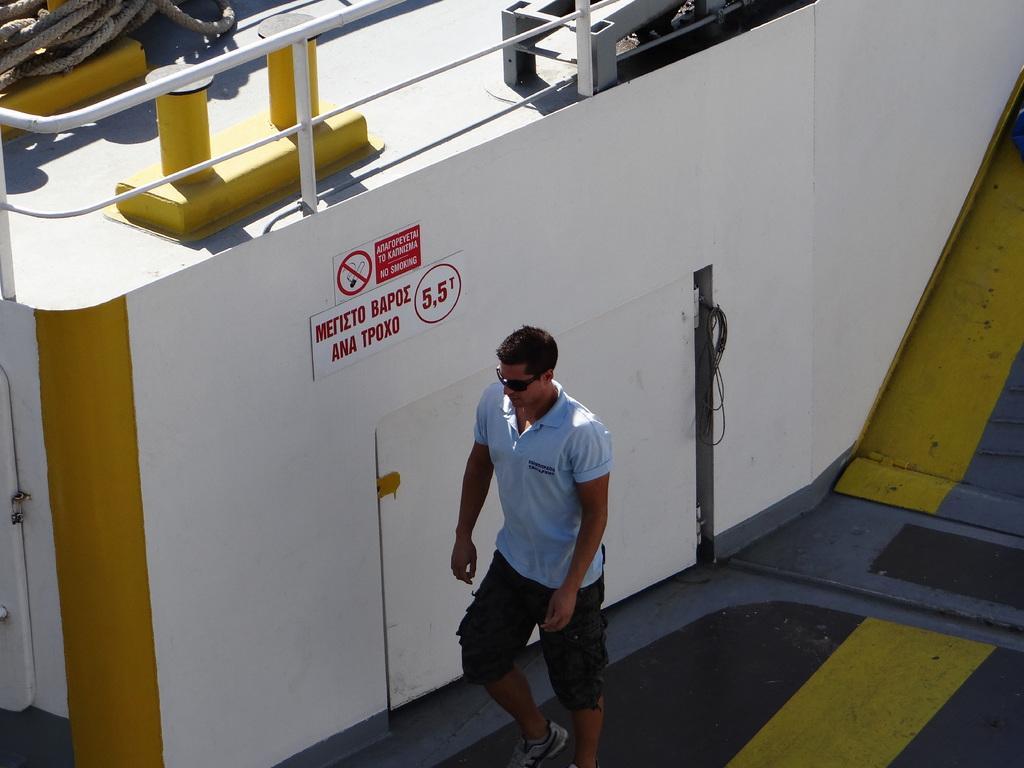Can you describe this image briefly? In this image, we can see a person wearing glasses and in the background, there are rods and we can see some boards on the wall and there are ropes. At the bottom, there is a floor. 